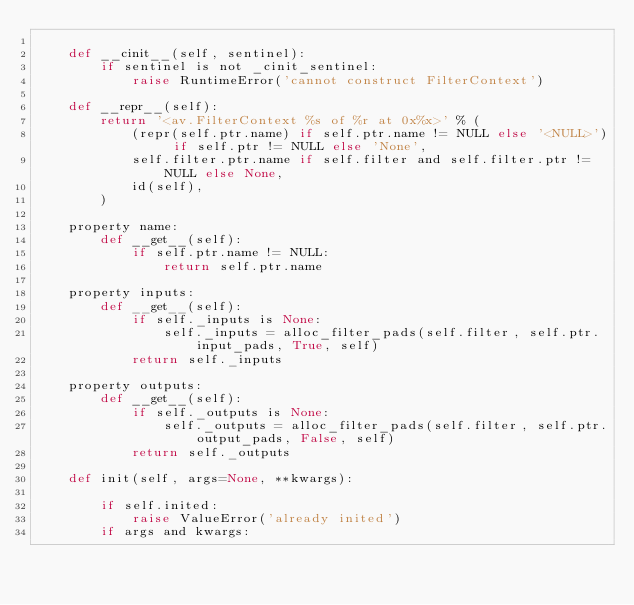Convert code to text. <code><loc_0><loc_0><loc_500><loc_500><_Cython_>
    def __cinit__(self, sentinel):
        if sentinel is not _cinit_sentinel:
            raise RuntimeError('cannot construct FilterContext')

    def __repr__(self):
        return '<av.FilterContext %s of %r at 0x%x>' % (
            (repr(self.ptr.name) if self.ptr.name != NULL else '<NULL>') if self.ptr != NULL else 'None',
            self.filter.ptr.name if self.filter and self.filter.ptr != NULL else None,
            id(self),
        )

    property name:
        def __get__(self):
            if self.ptr.name != NULL:
                return self.ptr.name

    property inputs:
        def __get__(self):
            if self._inputs is None:
                self._inputs = alloc_filter_pads(self.filter, self.ptr.input_pads, True, self)
            return self._inputs

    property outputs:
        def __get__(self):
            if self._outputs is None:
                self._outputs = alloc_filter_pads(self.filter, self.ptr.output_pads, False, self)
            return self._outputs

    def init(self, args=None, **kwargs):

        if self.inited:
            raise ValueError('already inited')
        if args and kwargs:</code> 